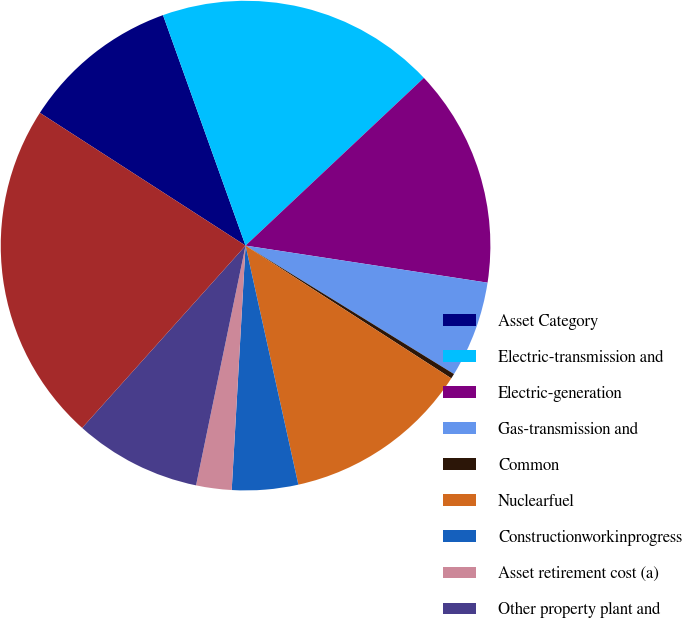<chart> <loc_0><loc_0><loc_500><loc_500><pie_chart><fcel>Asset Category<fcel>Electric-transmission and<fcel>Electric-generation<fcel>Gas-transmission and<fcel>Common<fcel>Nuclearfuel<fcel>Constructionworkinprogress<fcel>Asset retirement cost (a)<fcel>Other property plant and<fcel>Total property plant and<nl><fcel>10.4%<fcel>18.46%<fcel>14.43%<fcel>6.37%<fcel>0.33%<fcel>12.42%<fcel>4.36%<fcel>2.34%<fcel>8.39%<fcel>22.49%<nl></chart> 